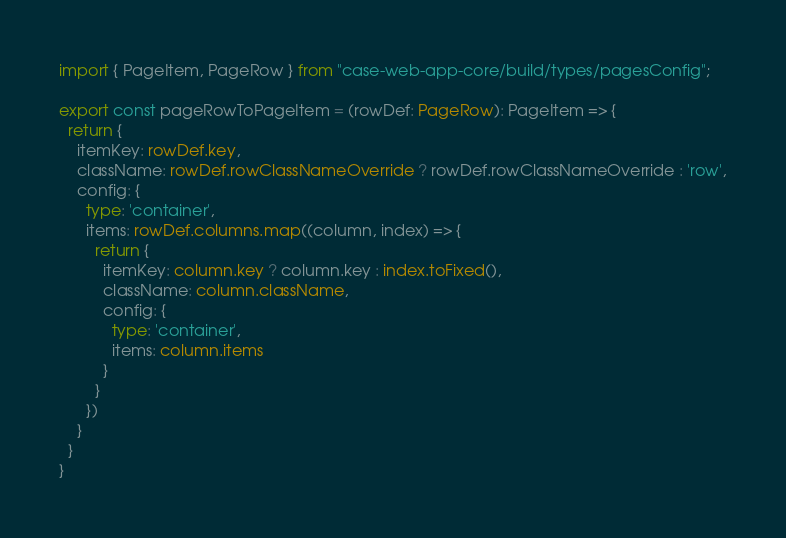<code> <loc_0><loc_0><loc_500><loc_500><_TypeScript_>import { PageItem, PageRow } from "case-web-app-core/build/types/pagesConfig";

export const pageRowToPageItem = (rowDef: PageRow): PageItem => {
  return {
    itemKey: rowDef.key,
    className: rowDef.rowClassNameOverride ? rowDef.rowClassNameOverride : 'row',
    config: {
      type: 'container',
      items: rowDef.columns.map((column, index) => {
        return {
          itemKey: column.key ? column.key : index.toFixed(),
          className: column.className,
          config: {
            type: 'container',
            items: column.items
          }
        }
      })
    }
  }
}
</code> 